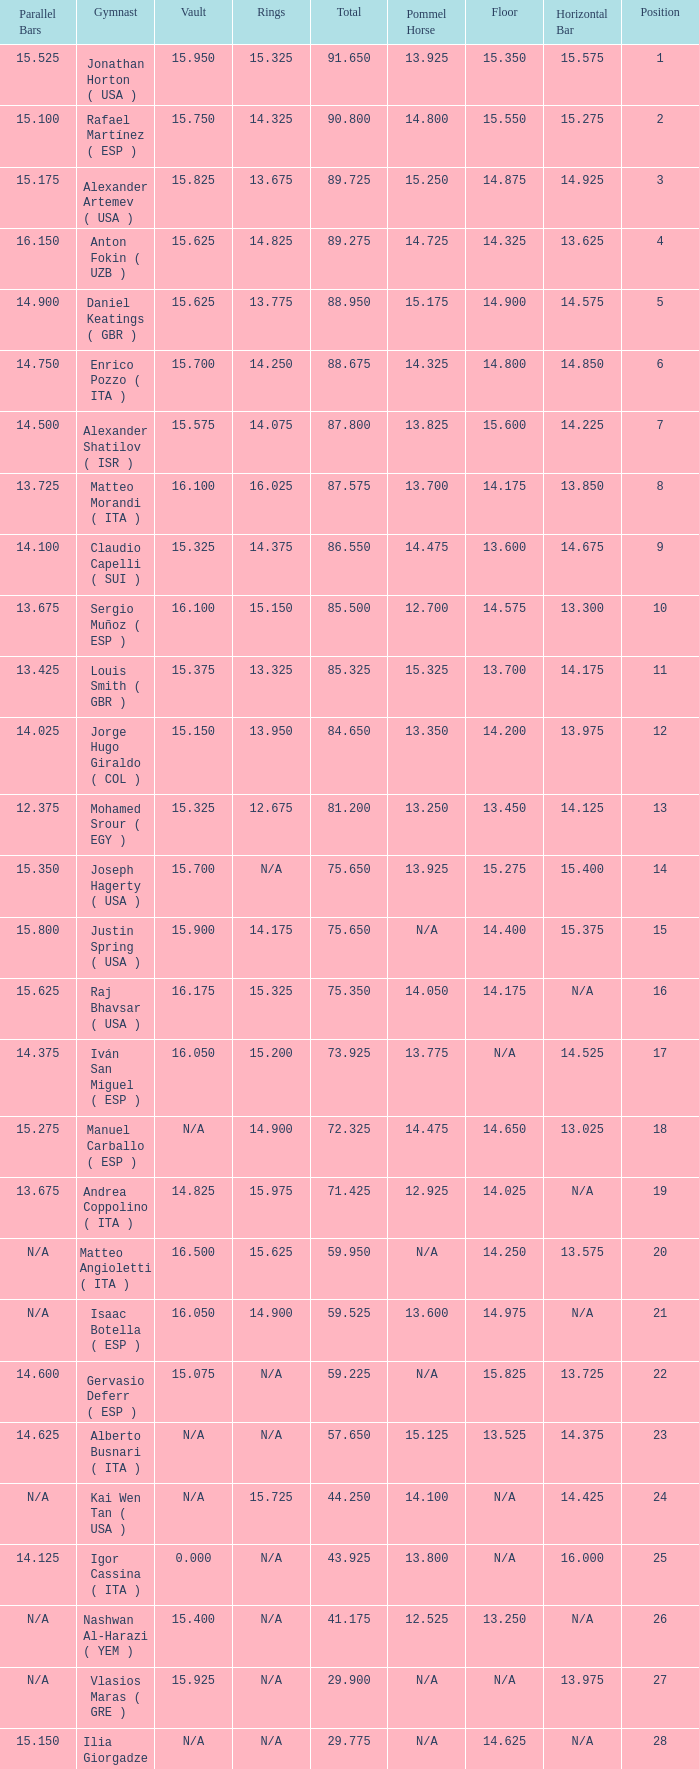If the parallel bars is 16.150, who is the gymnast? Anton Fokin ( UZB ). Could you parse the entire table? {'header': ['Parallel Bars', 'Gymnast', 'Vault', 'Rings', 'Total', 'Pommel Horse', 'Floor', 'Horizontal Bar', 'Position'], 'rows': [['15.525', 'Jonathan Horton ( USA )', '15.950', '15.325', '91.650', '13.925', '15.350', '15.575', '1'], ['15.100', 'Rafael Martínez ( ESP )', '15.750', '14.325', '90.800', '14.800', '15.550', '15.275', '2'], ['15.175', 'Alexander Artemev ( USA )', '15.825', '13.675', '89.725', '15.250', '14.875', '14.925', '3'], ['16.150', 'Anton Fokin ( UZB )', '15.625', '14.825', '89.275', '14.725', '14.325', '13.625', '4'], ['14.900', 'Daniel Keatings ( GBR )', '15.625', '13.775', '88.950', '15.175', '14.900', '14.575', '5'], ['14.750', 'Enrico Pozzo ( ITA )', '15.700', '14.250', '88.675', '14.325', '14.800', '14.850', '6'], ['14.500', 'Alexander Shatilov ( ISR )', '15.575', '14.075', '87.800', '13.825', '15.600', '14.225', '7'], ['13.725', 'Matteo Morandi ( ITA )', '16.100', '16.025', '87.575', '13.700', '14.175', '13.850', '8'], ['14.100', 'Claudio Capelli ( SUI )', '15.325', '14.375', '86.550', '14.475', '13.600', '14.675', '9'], ['13.675', 'Sergio Muñoz ( ESP )', '16.100', '15.150', '85.500', '12.700', '14.575', '13.300', '10'], ['13.425', 'Louis Smith ( GBR )', '15.375', '13.325', '85.325', '15.325', '13.700', '14.175', '11'], ['14.025', 'Jorge Hugo Giraldo ( COL )', '15.150', '13.950', '84.650', '13.350', '14.200', '13.975', '12'], ['12.375', 'Mohamed Srour ( EGY )', '15.325', '12.675', '81.200', '13.250', '13.450', '14.125', '13'], ['15.350', 'Joseph Hagerty ( USA )', '15.700', 'N/A', '75.650', '13.925', '15.275', '15.400', '14'], ['15.800', 'Justin Spring ( USA )', '15.900', '14.175', '75.650', 'N/A', '14.400', '15.375', '15'], ['15.625', 'Raj Bhavsar ( USA )', '16.175', '15.325', '75.350', '14.050', '14.175', 'N/A', '16'], ['14.375', 'Iván San Miguel ( ESP )', '16.050', '15.200', '73.925', '13.775', 'N/A', '14.525', '17'], ['15.275', 'Manuel Carballo ( ESP )', 'N/A', '14.900', '72.325', '14.475', '14.650', '13.025', '18'], ['13.675', 'Andrea Coppolino ( ITA )', '14.825', '15.975', '71.425', '12.925', '14.025', 'N/A', '19'], ['N/A', 'Matteo Angioletti ( ITA )', '16.500', '15.625', '59.950', 'N/A', '14.250', '13.575', '20'], ['N/A', 'Isaac Botella ( ESP )', '16.050', '14.900', '59.525', '13.600', '14.975', 'N/A', '21'], ['14.600', 'Gervasio Deferr ( ESP )', '15.075', 'N/A', '59.225', 'N/A', '15.825', '13.725', '22'], ['14.625', 'Alberto Busnari ( ITA )', 'N/A', 'N/A', '57.650', '15.125', '13.525', '14.375', '23'], ['N/A', 'Kai Wen Tan ( USA )', 'N/A', '15.725', '44.250', '14.100', 'N/A', '14.425', '24'], ['14.125', 'Igor Cassina ( ITA )', '0.000', 'N/A', '43.925', '13.800', 'N/A', '16.000', '25'], ['N/A', 'Nashwan Al-Harazi ( YEM )', '15.400', 'N/A', '41.175', '12.525', '13.250', 'N/A', '26'], ['N/A', 'Vlasios Maras ( GRE )', '15.925', 'N/A', '29.900', 'N/A', 'N/A', '13.975', '27'], ['15.150', 'Ilia Giorgadze ( GEO )', 'N/A', 'N/A', '29.775', 'N/A', '14.625', 'N/A', '28'], ['N/A', 'Christoph Schärer ( SUI )', 'N/A', 'N/A', '28.500', '13.150', 'N/A', '15.350', '29'], ['N/A', 'Leszek Blanik ( POL )', '16.700', 'N/A', '16.700', 'N/A', 'N/A', 'N/A', '30']]} 